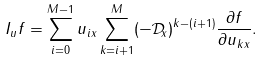<formula> <loc_0><loc_0><loc_500><loc_500>I _ { u } f = \sum _ { i = 0 } ^ { M - 1 } u _ { i x } \sum _ { k = i + 1 } ^ { M } ( - { \mathcal { D } } _ { x } ) ^ { k - ( i + 1 ) } \frac { \partial f } { \partial u _ { k x } } .</formula> 